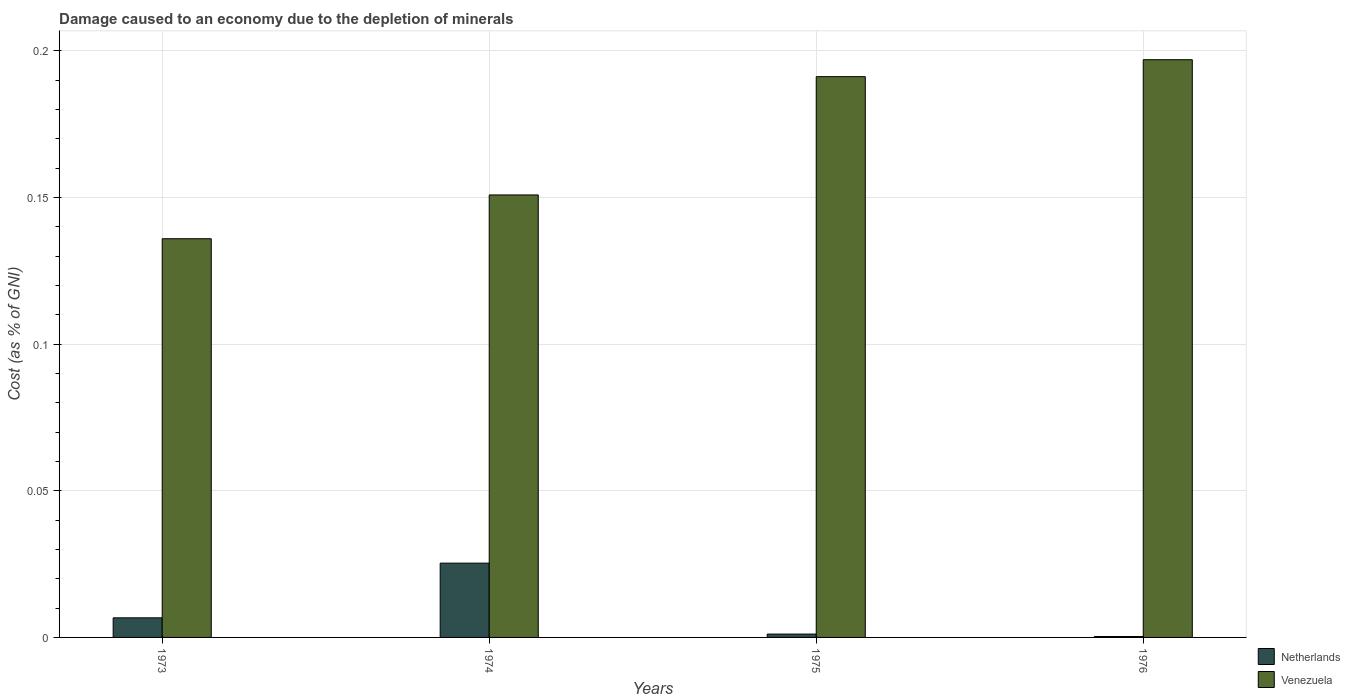Are the number of bars per tick equal to the number of legend labels?
Keep it short and to the point. Yes. What is the label of the 2nd group of bars from the left?
Your response must be concise. 1974. In how many cases, is the number of bars for a given year not equal to the number of legend labels?
Your answer should be very brief. 0. What is the cost of damage caused due to the depletion of minerals in Netherlands in 1976?
Make the answer very short. 0. Across all years, what is the maximum cost of damage caused due to the depletion of minerals in Venezuela?
Provide a succinct answer. 0.2. Across all years, what is the minimum cost of damage caused due to the depletion of minerals in Netherlands?
Offer a very short reply. 0. In which year was the cost of damage caused due to the depletion of minerals in Netherlands maximum?
Provide a succinct answer. 1974. In which year was the cost of damage caused due to the depletion of minerals in Netherlands minimum?
Give a very brief answer. 1976. What is the total cost of damage caused due to the depletion of minerals in Netherlands in the graph?
Offer a terse response. 0.03. What is the difference between the cost of damage caused due to the depletion of minerals in Netherlands in 1974 and that in 1975?
Provide a succinct answer. 0.02. What is the difference between the cost of damage caused due to the depletion of minerals in Netherlands in 1975 and the cost of damage caused due to the depletion of minerals in Venezuela in 1976?
Offer a terse response. -0.2. What is the average cost of damage caused due to the depletion of minerals in Netherlands per year?
Ensure brevity in your answer.  0.01. In the year 1974, what is the difference between the cost of damage caused due to the depletion of minerals in Venezuela and cost of damage caused due to the depletion of minerals in Netherlands?
Ensure brevity in your answer.  0.13. In how many years, is the cost of damage caused due to the depletion of minerals in Venezuela greater than 0.01 %?
Keep it short and to the point. 4. What is the ratio of the cost of damage caused due to the depletion of minerals in Netherlands in 1973 to that in 1976?
Provide a succinct answer. 21.36. What is the difference between the highest and the second highest cost of damage caused due to the depletion of minerals in Netherlands?
Your response must be concise. 0.02. What is the difference between the highest and the lowest cost of damage caused due to the depletion of minerals in Netherlands?
Your answer should be very brief. 0.03. In how many years, is the cost of damage caused due to the depletion of minerals in Netherlands greater than the average cost of damage caused due to the depletion of minerals in Netherlands taken over all years?
Your response must be concise. 1. Is the sum of the cost of damage caused due to the depletion of minerals in Venezuela in 1975 and 1976 greater than the maximum cost of damage caused due to the depletion of minerals in Netherlands across all years?
Your answer should be compact. Yes. What does the 2nd bar from the left in 1973 represents?
Offer a very short reply. Venezuela. What does the 1st bar from the right in 1975 represents?
Give a very brief answer. Venezuela. How many bars are there?
Ensure brevity in your answer.  8. Are all the bars in the graph horizontal?
Provide a succinct answer. No. What is the difference between two consecutive major ticks on the Y-axis?
Give a very brief answer. 0.05. Are the values on the major ticks of Y-axis written in scientific E-notation?
Give a very brief answer. No. Does the graph contain grids?
Keep it short and to the point. Yes. What is the title of the graph?
Provide a succinct answer. Damage caused to an economy due to the depletion of minerals. What is the label or title of the Y-axis?
Your answer should be compact. Cost (as % of GNI). What is the Cost (as % of GNI) in Netherlands in 1973?
Your answer should be very brief. 0.01. What is the Cost (as % of GNI) in Venezuela in 1973?
Ensure brevity in your answer.  0.14. What is the Cost (as % of GNI) in Netherlands in 1974?
Provide a short and direct response. 0.03. What is the Cost (as % of GNI) in Venezuela in 1974?
Ensure brevity in your answer.  0.15. What is the Cost (as % of GNI) in Netherlands in 1975?
Provide a succinct answer. 0. What is the Cost (as % of GNI) of Venezuela in 1975?
Your response must be concise. 0.19. What is the Cost (as % of GNI) in Netherlands in 1976?
Your answer should be very brief. 0. What is the Cost (as % of GNI) in Venezuela in 1976?
Offer a terse response. 0.2. Across all years, what is the maximum Cost (as % of GNI) in Netherlands?
Give a very brief answer. 0.03. Across all years, what is the maximum Cost (as % of GNI) of Venezuela?
Make the answer very short. 0.2. Across all years, what is the minimum Cost (as % of GNI) in Netherlands?
Your answer should be very brief. 0. Across all years, what is the minimum Cost (as % of GNI) in Venezuela?
Make the answer very short. 0.14. What is the total Cost (as % of GNI) of Netherlands in the graph?
Offer a very short reply. 0.03. What is the total Cost (as % of GNI) of Venezuela in the graph?
Your response must be concise. 0.68. What is the difference between the Cost (as % of GNI) of Netherlands in 1973 and that in 1974?
Provide a short and direct response. -0.02. What is the difference between the Cost (as % of GNI) of Venezuela in 1973 and that in 1974?
Offer a very short reply. -0.01. What is the difference between the Cost (as % of GNI) in Netherlands in 1973 and that in 1975?
Offer a very short reply. 0.01. What is the difference between the Cost (as % of GNI) of Venezuela in 1973 and that in 1975?
Your answer should be compact. -0.06. What is the difference between the Cost (as % of GNI) in Netherlands in 1973 and that in 1976?
Your answer should be compact. 0.01. What is the difference between the Cost (as % of GNI) in Venezuela in 1973 and that in 1976?
Offer a very short reply. -0.06. What is the difference between the Cost (as % of GNI) of Netherlands in 1974 and that in 1975?
Provide a short and direct response. 0.02. What is the difference between the Cost (as % of GNI) of Venezuela in 1974 and that in 1975?
Provide a succinct answer. -0.04. What is the difference between the Cost (as % of GNI) in Netherlands in 1974 and that in 1976?
Your answer should be compact. 0.03. What is the difference between the Cost (as % of GNI) in Venezuela in 1974 and that in 1976?
Keep it short and to the point. -0.05. What is the difference between the Cost (as % of GNI) in Netherlands in 1975 and that in 1976?
Ensure brevity in your answer.  0. What is the difference between the Cost (as % of GNI) of Venezuela in 1975 and that in 1976?
Keep it short and to the point. -0.01. What is the difference between the Cost (as % of GNI) of Netherlands in 1973 and the Cost (as % of GNI) of Venezuela in 1974?
Give a very brief answer. -0.14. What is the difference between the Cost (as % of GNI) in Netherlands in 1973 and the Cost (as % of GNI) in Venezuela in 1975?
Provide a short and direct response. -0.18. What is the difference between the Cost (as % of GNI) in Netherlands in 1973 and the Cost (as % of GNI) in Venezuela in 1976?
Provide a short and direct response. -0.19. What is the difference between the Cost (as % of GNI) in Netherlands in 1974 and the Cost (as % of GNI) in Venezuela in 1975?
Your response must be concise. -0.17. What is the difference between the Cost (as % of GNI) in Netherlands in 1974 and the Cost (as % of GNI) in Venezuela in 1976?
Make the answer very short. -0.17. What is the difference between the Cost (as % of GNI) in Netherlands in 1975 and the Cost (as % of GNI) in Venezuela in 1976?
Keep it short and to the point. -0.2. What is the average Cost (as % of GNI) in Netherlands per year?
Provide a succinct answer. 0.01. What is the average Cost (as % of GNI) of Venezuela per year?
Ensure brevity in your answer.  0.17. In the year 1973, what is the difference between the Cost (as % of GNI) in Netherlands and Cost (as % of GNI) in Venezuela?
Your answer should be very brief. -0.13. In the year 1974, what is the difference between the Cost (as % of GNI) of Netherlands and Cost (as % of GNI) of Venezuela?
Offer a very short reply. -0.13. In the year 1975, what is the difference between the Cost (as % of GNI) in Netherlands and Cost (as % of GNI) in Venezuela?
Make the answer very short. -0.19. In the year 1976, what is the difference between the Cost (as % of GNI) in Netherlands and Cost (as % of GNI) in Venezuela?
Provide a succinct answer. -0.2. What is the ratio of the Cost (as % of GNI) in Netherlands in 1973 to that in 1974?
Your answer should be compact. 0.26. What is the ratio of the Cost (as % of GNI) of Venezuela in 1973 to that in 1974?
Offer a terse response. 0.9. What is the ratio of the Cost (as % of GNI) of Netherlands in 1973 to that in 1975?
Give a very brief answer. 5.87. What is the ratio of the Cost (as % of GNI) in Venezuela in 1973 to that in 1975?
Ensure brevity in your answer.  0.71. What is the ratio of the Cost (as % of GNI) in Netherlands in 1973 to that in 1976?
Your response must be concise. 21.36. What is the ratio of the Cost (as % of GNI) in Venezuela in 1973 to that in 1976?
Offer a terse response. 0.69. What is the ratio of the Cost (as % of GNI) of Netherlands in 1974 to that in 1975?
Keep it short and to the point. 22.27. What is the ratio of the Cost (as % of GNI) in Venezuela in 1974 to that in 1975?
Your answer should be compact. 0.79. What is the ratio of the Cost (as % of GNI) in Netherlands in 1974 to that in 1976?
Your answer should be compact. 81.01. What is the ratio of the Cost (as % of GNI) of Venezuela in 1974 to that in 1976?
Provide a short and direct response. 0.77. What is the ratio of the Cost (as % of GNI) of Netherlands in 1975 to that in 1976?
Ensure brevity in your answer.  3.64. What is the ratio of the Cost (as % of GNI) of Venezuela in 1975 to that in 1976?
Your answer should be very brief. 0.97. What is the difference between the highest and the second highest Cost (as % of GNI) of Netherlands?
Your answer should be very brief. 0.02. What is the difference between the highest and the second highest Cost (as % of GNI) in Venezuela?
Offer a terse response. 0.01. What is the difference between the highest and the lowest Cost (as % of GNI) in Netherlands?
Your answer should be compact. 0.03. What is the difference between the highest and the lowest Cost (as % of GNI) of Venezuela?
Offer a terse response. 0.06. 